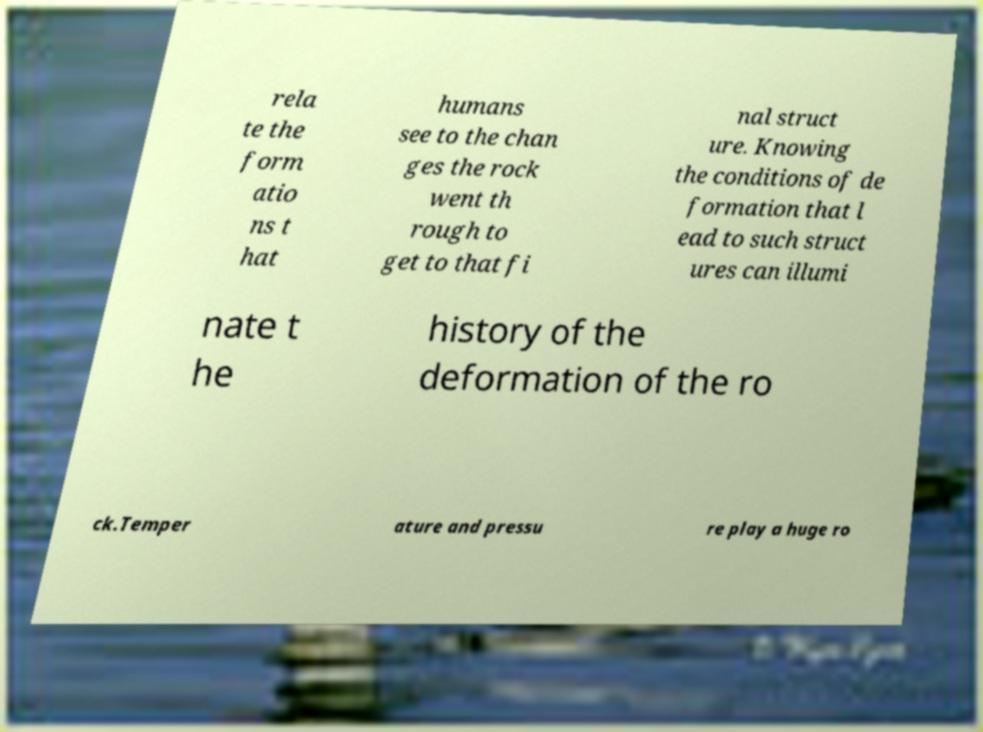Please read and relay the text visible in this image. What does it say? rela te the form atio ns t hat humans see to the chan ges the rock went th rough to get to that fi nal struct ure. Knowing the conditions of de formation that l ead to such struct ures can illumi nate t he history of the deformation of the ro ck.Temper ature and pressu re play a huge ro 